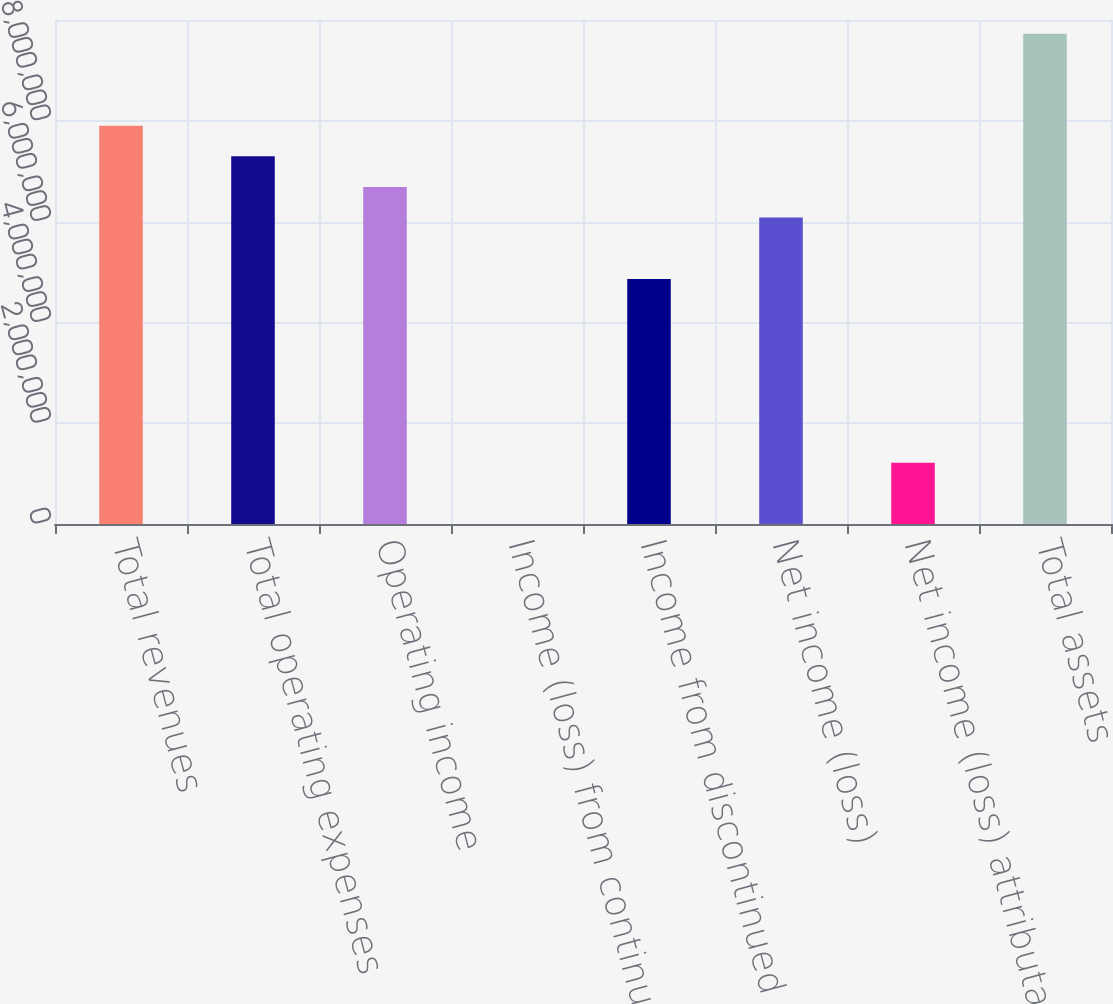<chart> <loc_0><loc_0><loc_500><loc_500><bar_chart><fcel>Total revenues<fcel>Total operating expenses<fcel>Operating income<fcel>Income (loss) from continuing<fcel>Income from discontinued<fcel>Net income (loss)<fcel>Net income (loss) attributable<fcel>Total assets<nl><fcel>7.90324e+06<fcel>7.2953e+06<fcel>6.68735e+06<fcel>0.29<fcel>4.86353e+06<fcel>6.07941e+06<fcel>1.21588e+06<fcel>9.72706e+06<nl></chart> 